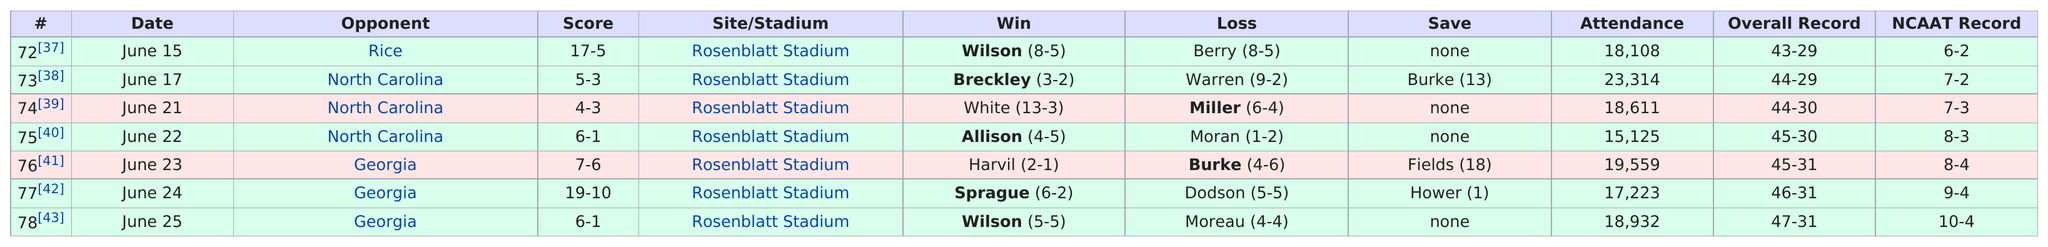Give some essential details in this illustration. On June 23, 2022, Rosenblatt Stadium's attendance was greater than the previous day. Seventy games were played at Rosenblatt Stadium. On June 25, Moreau scored the least points among all players, with a score of 4-4. The game with the highest attendance was number 73. On June 21, the opponent who had the highest attendance after North Carolina was Georgia. 